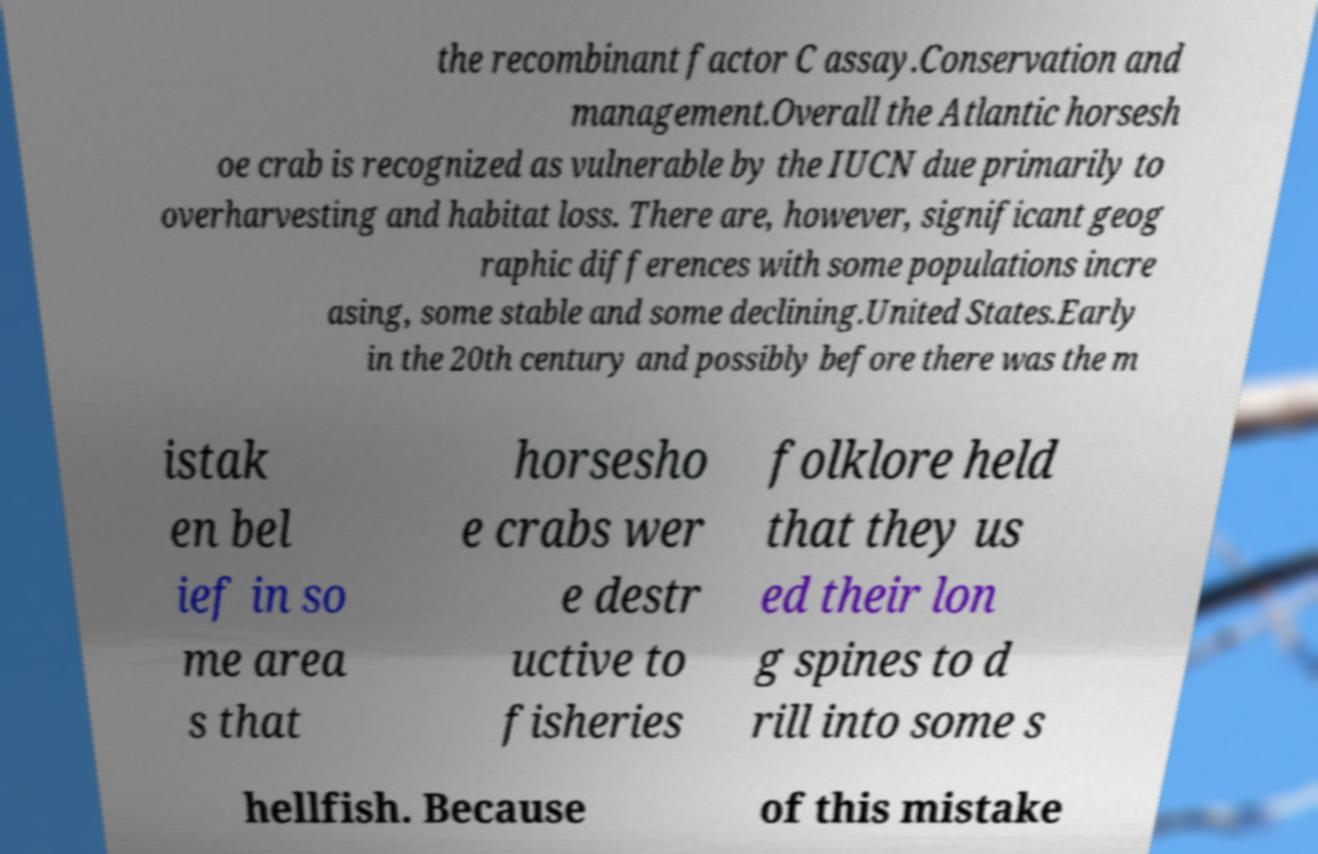I need the written content from this picture converted into text. Can you do that? the recombinant factor C assay.Conservation and management.Overall the Atlantic horsesh oe crab is recognized as vulnerable by the IUCN due primarily to overharvesting and habitat loss. There are, however, significant geog raphic differences with some populations incre asing, some stable and some declining.United States.Early in the 20th century and possibly before there was the m istak en bel ief in so me area s that horsesho e crabs wer e destr uctive to fisheries folklore held that they us ed their lon g spines to d rill into some s hellfish. Because of this mistake 